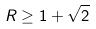Convert formula to latex. <formula><loc_0><loc_0><loc_500><loc_500>R \geq 1 + \sqrt { 2 }</formula> 